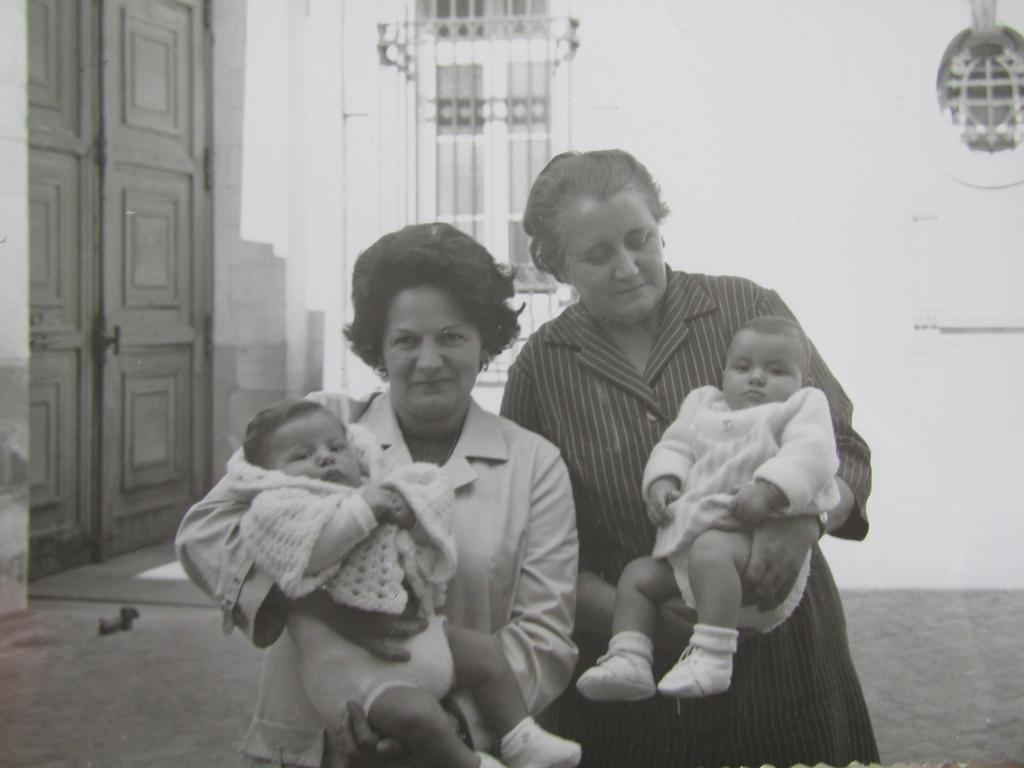How many people are in the image? There are two persons in the image. What are the persons holding? The persons are holding babies. What architectural features can be seen in the background of the image? There is a door and a window in the background of the image. Where are the door and window located in the image? The door and window are on a wall in the background. What type of wax is being used by the committee in the image? There is no committee or wax present in the image. 